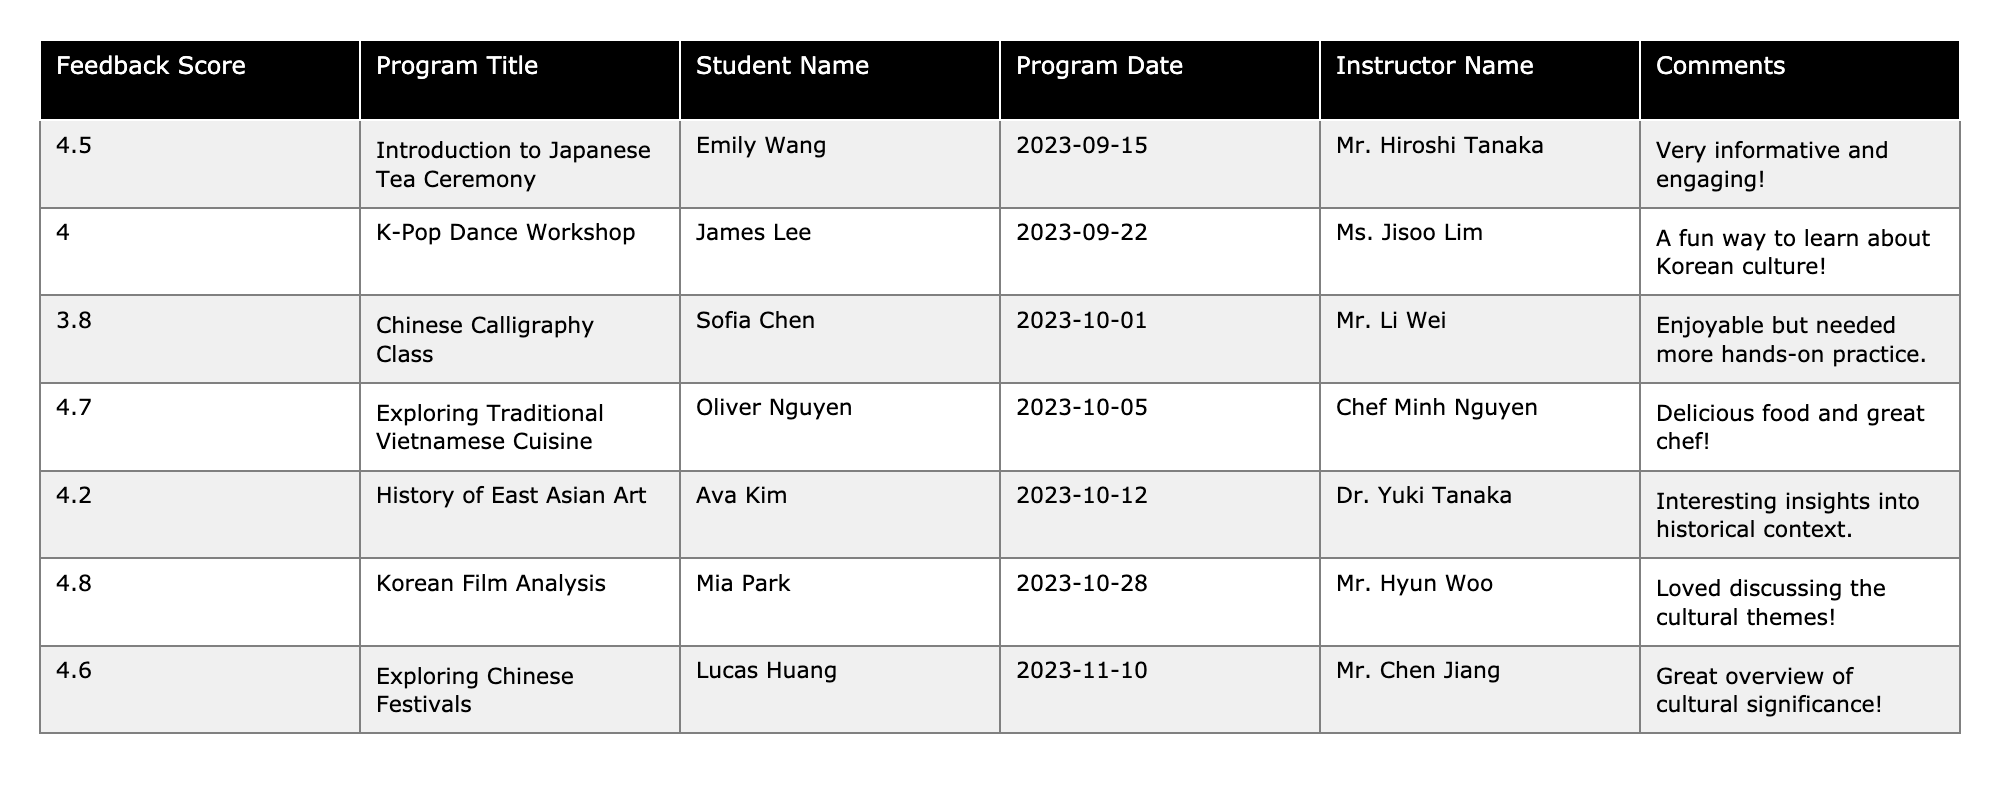What is the highest feedback score received from a program? The table shows that the highest feedback score is 4.8, which corresponds to the program "Korean Film Analysis."
Answer: 4.8 Which program had the lowest feedback score? The table indicates that the program with the lowest score is "Chinese Calligraphy Class," with a feedback score of 3.8.
Answer: Chinese Calligraphy Class Who was the instructor for the "Exploring Traditional Vietnamese Cuisine" program? By looking at the table, the program "Exploring Traditional Vietnamese Cuisine" was conducted by Chef Minh Nguyen.
Answer: Chef Minh Nguyen What was the average feedback score across all programs? Calculating the average involves summing the scores (4.5 + 4.0 + 3.8 + 4.7 + 4.2 + 4.8 + 4.6) = 30.6 and dividing by the number of programs (7), which gives us 30.6/7 ≈ 4.37.
Answer: 4.37 How many programs have a feedback score of 4.5 or higher? Checking the table, the programs with scores of 4.5 or higher are "Introduction to Japanese Tea Ceremony," "Exploring Traditional Vietnamese Cuisine," "Korean Film Analysis," "Exploring Chinese Festivals," and "History of East Asian Art." That makes five programs.
Answer: 5 Is there any program that received a feedback score of exactly 4.0? Referring to the table, there is indeed a program, "K-Pop Dance Workshop," that has a feedback score of exactly 4.0.
Answer: Yes Which program's comments were the most positive? The comments for "Korean Film Analysis" note a love for discussing cultural themes, which can be interpreted as very positive, and the score is also high (4.8), suggesting it stands out in both scores and feedback.
Answer: Korean Film Analysis What is the difference between the highest and lowest feedback scores? The highest score is 4.8 (for "Korean Film Analysis") and the lowest is 3.8 (for "Chinese Calligraphy Class"). The difference is calculated as 4.8 - 3.8 = 1.0.
Answer: 1.0 Which instructor received the highest-rated feedback based on student comments? Analyzing the scores and comments, Mr. Hyun Woo for "Korean Film Analysis" received the highest score (4.8) and favorable comments.
Answer: Mr. Hyun Woo Did the program "Chinese Calligraphy Class" receive positive remarks in the comments section? Although the program had a score of 3.8, the comments mention it was enjoyable, but it needed more hands-on practice, indicating a mixed feedback rather than entirely positive remarks.
Answer: No 